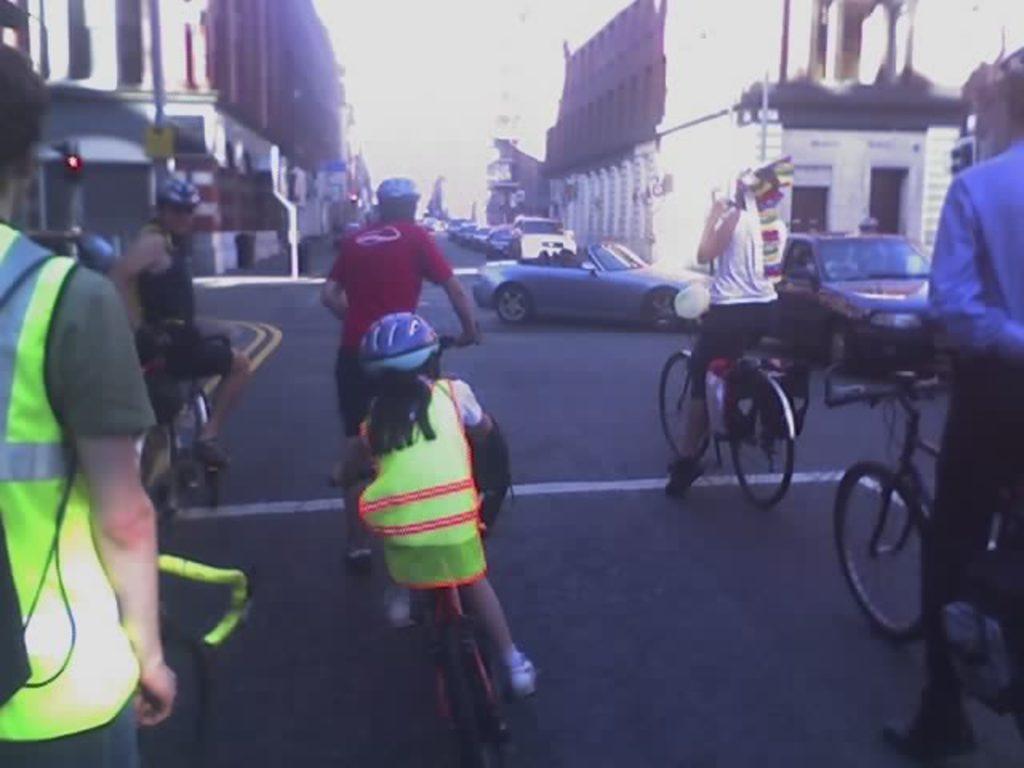How would you summarize this image in a sentence or two? This picture describe that a group girl and boy are riding a bicycle on the road, From the center this small girl wearing a yellow jacket and helmet riding a bicycle, from right we can see that a blue car is crossing toward the right path and red building seen on both side. and traffic signal light on the left. 